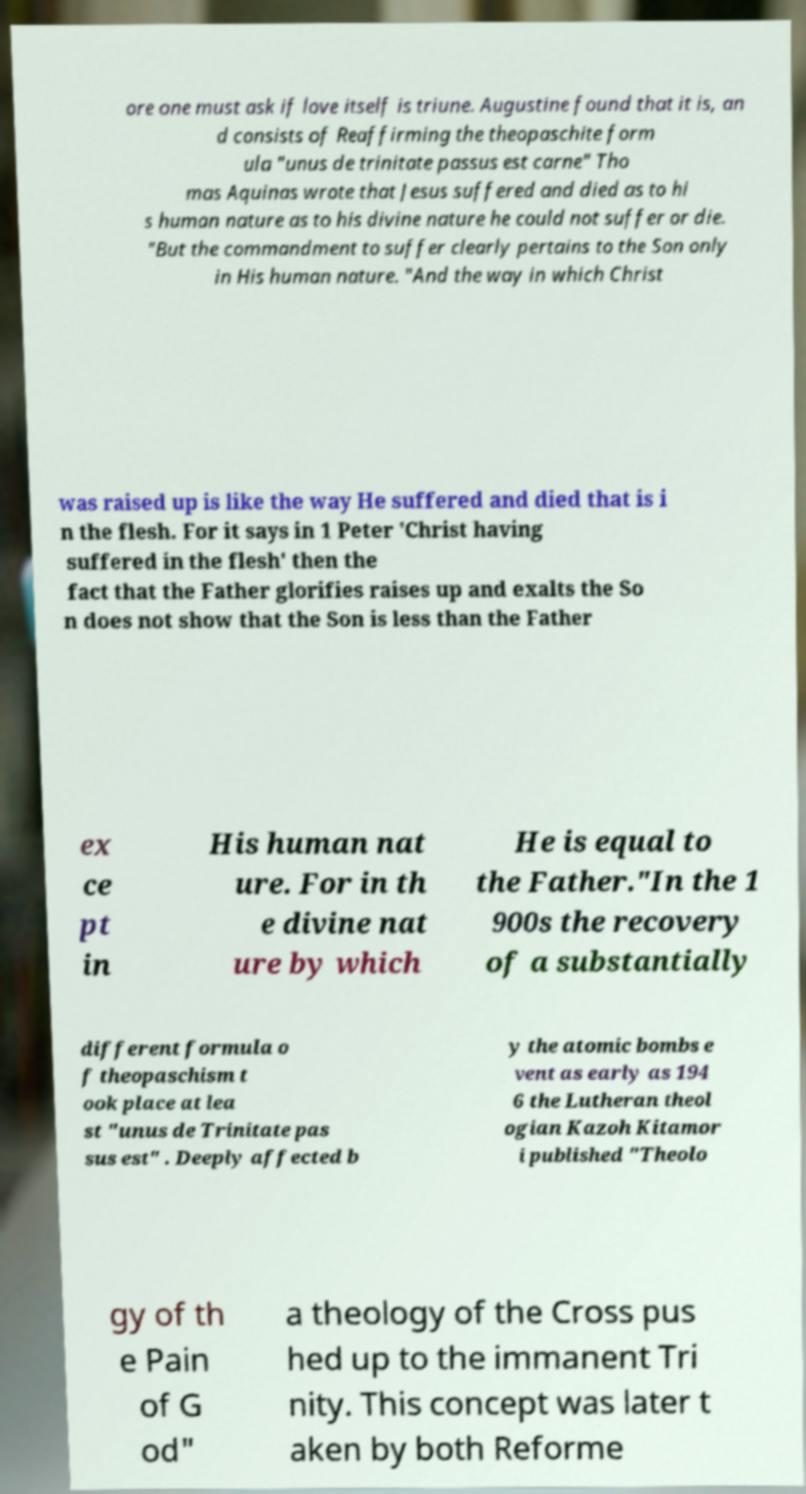Can you read and provide the text displayed in the image?This photo seems to have some interesting text. Can you extract and type it out for me? ore one must ask if love itself is triune. Augustine found that it is, an d consists of Reaffirming the theopaschite form ula "unus de trinitate passus est carne" Tho mas Aquinas wrote that Jesus suffered and died as to hi s human nature as to his divine nature he could not suffer or die. "But the commandment to suffer clearly pertains to the Son only in His human nature. "And the way in which Christ was raised up is like the way He suffered and died that is i n the flesh. For it says in 1 Peter 'Christ having suffered in the flesh' then the fact that the Father glorifies raises up and exalts the So n does not show that the Son is less than the Father ex ce pt in His human nat ure. For in th e divine nat ure by which He is equal to the Father."In the 1 900s the recovery of a substantially different formula o f theopaschism t ook place at lea st "unus de Trinitate pas sus est" . Deeply affected b y the atomic bombs e vent as early as 194 6 the Lutheran theol ogian Kazoh Kitamor i published "Theolo gy of th e Pain of G od" a theology of the Cross pus hed up to the immanent Tri nity. This concept was later t aken by both Reforme 